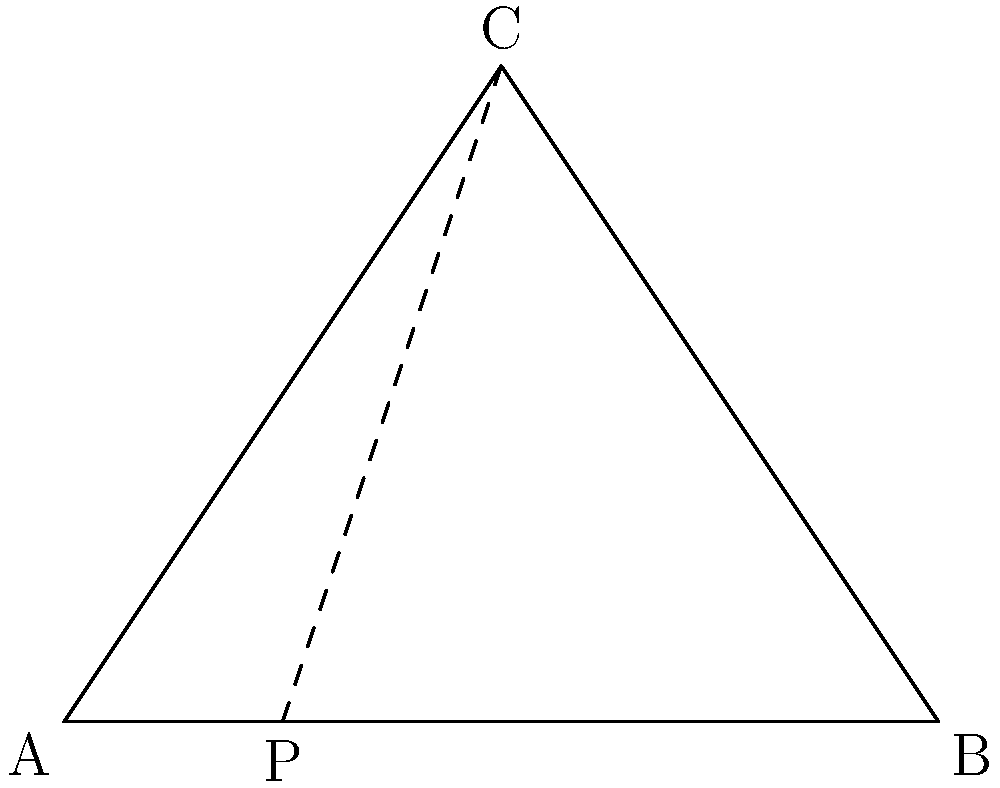During the Ironman 70.3 Muskoka race, you need to swim across a triangular lake. The shortest path from point A to point C is not a straight line, but rather involves swimming to a point P on the opposite shore and then running to C. If AB = 8 km, BC = 6 km, and AC = 7 km, what is the total distance of the optimal path from A to C (swimming + running)? Let's approach this step-by-step:

1) First, we need to find the height of the triangle. We can do this using Heron's formula:
   
   $s = \frac{a+b+c}{2} = \frac{8+6+7}{2} = 10.5$
   
   $Area = \sqrt{s(s-a)(s-b)(s-c)} = \sqrt{10.5(10.5-8)(10.5-6)(10.5-7)} = 20.33$ km²

2) The height (h) can be calculated as: $h = \frac{2 * Area}{base} = \frac{2 * 20.33}{8} = 5.08$ km

3) Now, let's call the distance AP as x. The total distance will be:

   $d = \sqrt{x^2 + h^2} + \sqrt{(8-x)^2 + h^2}$

4) To minimize this, we differentiate with respect to x and set it to zero:

   $\frac{d}{dx}(d) = \frac{x}{\sqrt{x^2 + h^2}} - \frac{8-x}{\sqrt{(8-x)^2 + h^2}} = 0$

5) This equation is satisfied when the two fractions are equal, which occurs when x = 4 (half of AB).

6) Therefore, the optimal path is when P is the midpoint of AB.

7) The total distance is then:

   $d = \sqrt{4^2 + 5.08^2} + \sqrt{4^2 + 5.08^2} = 2 * \sqrt{4^2 + 5.08^2} = 2 * 6.47 = 12.94$ km
Answer: 12.94 km 